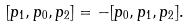Convert formula to latex. <formula><loc_0><loc_0><loc_500><loc_500>[ p _ { 1 } , p _ { 0 } , p _ { 2 } ] = - [ p _ { 0 } , p _ { 1 } , p _ { 2 } ] .</formula> 